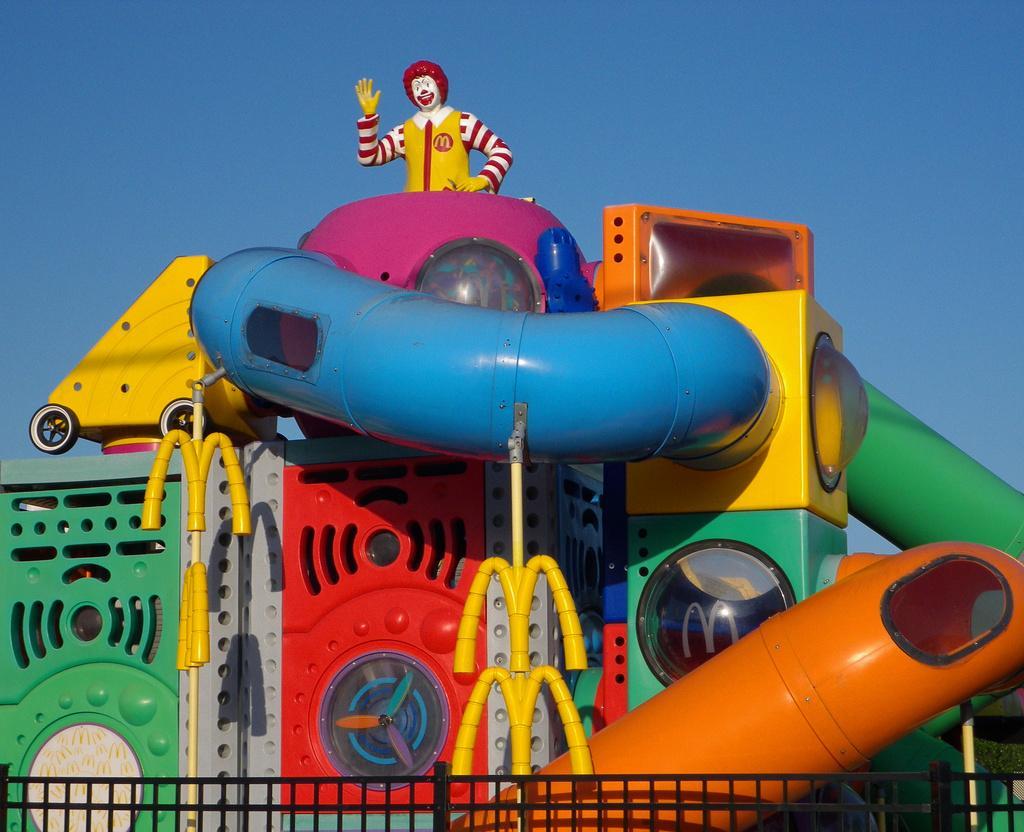Can you describe this image briefly? Here we can see an amusement ride, fence, and a statue. In the background there is sky. 